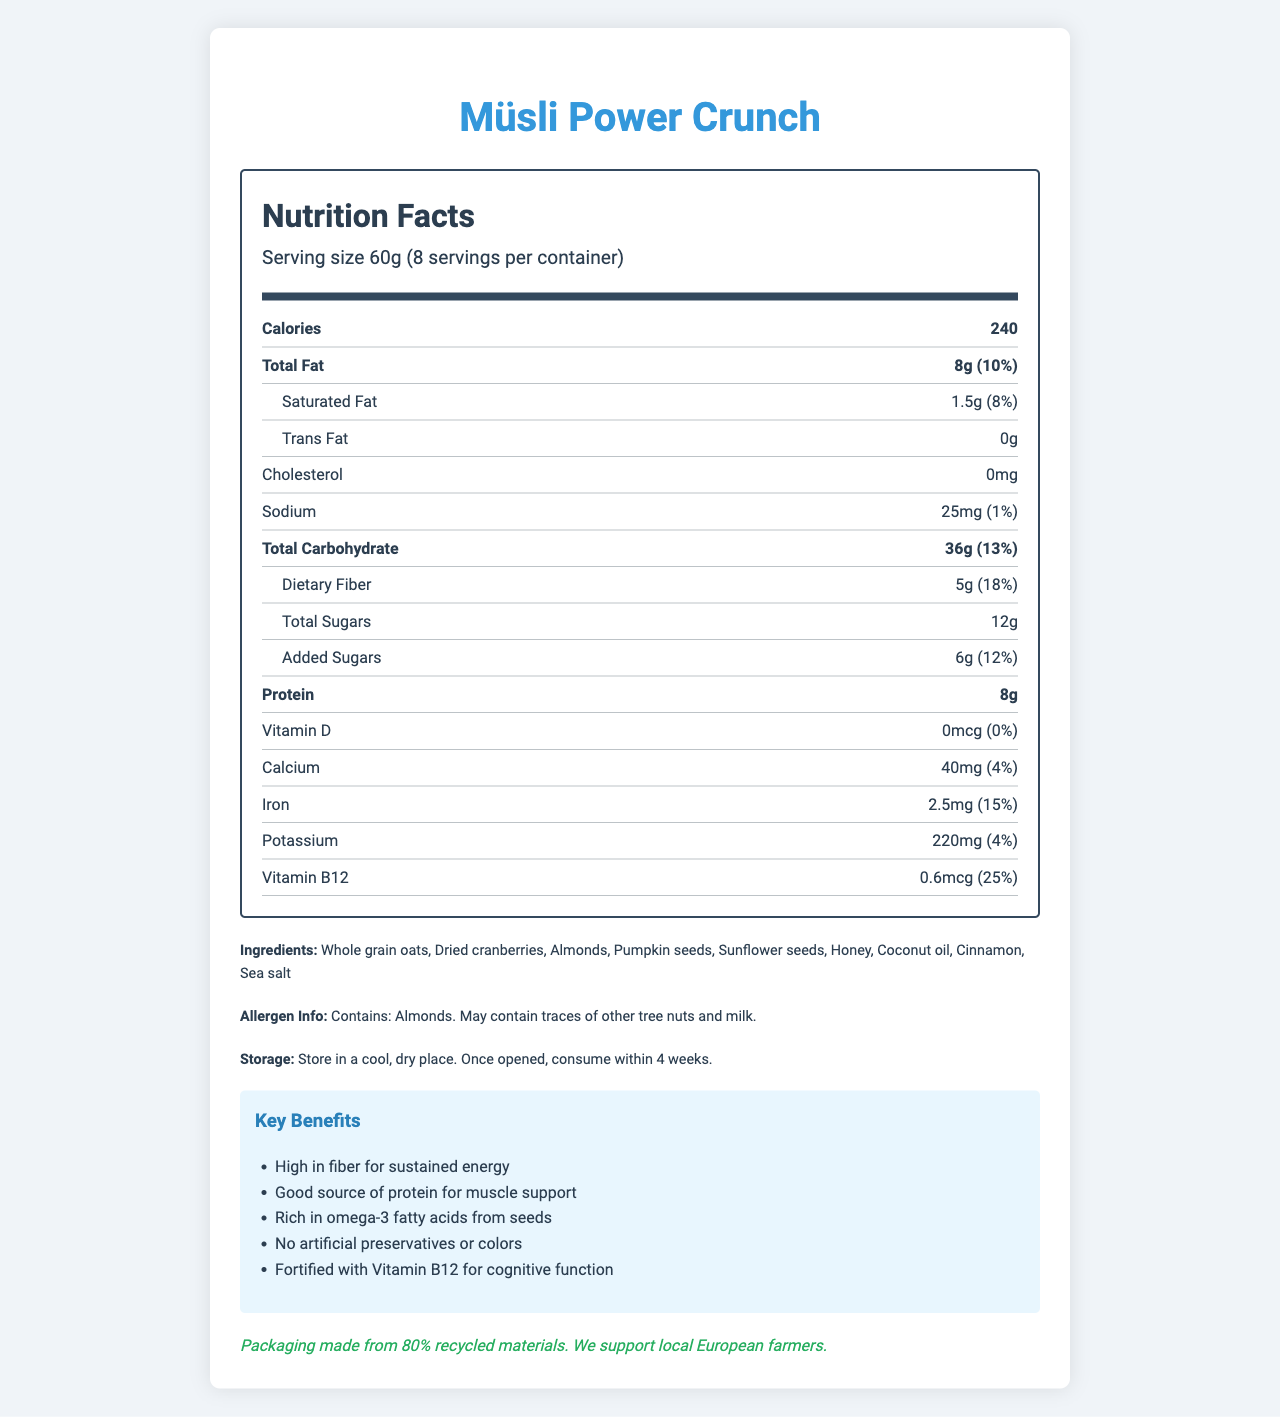what is the serving size? The serving size is listed near the top of the Nutrition Facts section as "Serving size 60g."
Answer: 60g How many servings are there per container? This information is provided right below the serving size in the Nutrition Facts section, indicating "8 servings per container."
Answer: 8 How many calories are in a serving? Calories per serving are prominently displayed in the Nutrition Facts section as "240."
Answer: 240 What are the main ingredients in the Müsli Power Crunch? These are listed under the "Ingredients" section near the bottom of the document.
Answer: Whole grain oats, Dried cranberries, Almonds, Pumpkin seeds, Sunflower seeds, Honey, Coconut oil, Cinnamon, Sea salt How much protein does one serving contain? This information is found in the Nutrition Facts section under the "Protein" line.
Answer: 8g What percentage of the daily value for dietary fiber does one serving provide? This is listed in the Nutrition Facts section under "Dietary Fiber" as "18%."
Answer: 18% Does the product contain any vitamin D? The Nutrition Facts section shows Vitamin D as "0mcg," with a corresponding daily value of "0%."
Answer: No Which of the following is not a benefit of Müsli Power Crunch? A. High in fiber B. Good source of vitamin C C. Good source of protein The benefits list includes "High in fiber" and "Good source of protein," but does not mention vitamin C.
Answer: B How much added sugars are in one serving of this product? A. 10g B. 8g C. 6g In the Nutrition Facts section, "Added Sugars" is listed as "6g."
Answer: C Is Müsli Power Crunch produced in the USA? The manufacturer is EuroNutri GmbH, located in Berlin, Germany, as listed at the bottom of the document.
Answer: No Summarize the document. The summary covers key aspects including nutrition details, benefits, ingredients, storage, allergens, and sustainability, giving a comprehensive overview of the product.
Answer: The document details the Nutrition Facts of Müsli Power Crunch, a popular breakfast option among European university students, providing information on serving size, servings per container, and nutrient content per serving. It highlights key benefits such as high fiber and protein content, lists the ingredients, storage instructions, allergen information, and sustainability notes. Can the exact amount of omega-3 fatty acids be determined from the provided information? The document mentions that the product is "Rich in omega-3 fatty acids from seeds," but does not provide exact amounts.
Answer: No How long can the product be stored once opened? The storage instructions state: "Once opened, consume within 4 weeks."
Answer: 4 weeks What is the amount of iron in one serving and its percentage daily value? The Nutrition Facts section lists Iron as 2.5mg, with a daily value of 15%.
Answer: 2.5mg, 15% How many grams of total fat does the Müsli Power Crunch have per serving? The total fat content per serving is displayed as "8g" in the Nutrition Facts section.
Answer: 8g What is the storage instruction for this product? These instructions are listed under the "Storage" section near the bottom of the document.
Answer: Store in a cool, dry place. Once opened, consume within 4 weeks. Which ingredient might cause an allergic reaction to someone allergic to tree nuts? The allergen information specifically notes that the product contains Almonds and may contain traces of other tree nuts.
Answer: Almonds 